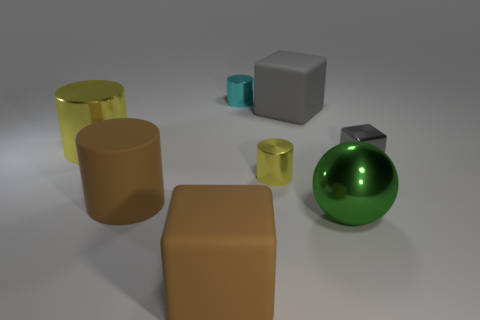Add 2 gray balls. How many objects exist? 10 Subtract all blocks. How many objects are left? 5 Add 2 big cyan cylinders. How many big cyan cylinders exist? 2 Subtract 0 blue spheres. How many objects are left? 8 Subtract all large green spheres. Subtract all yellow shiny cylinders. How many objects are left? 5 Add 1 small gray metal cubes. How many small gray metal cubes are left? 2 